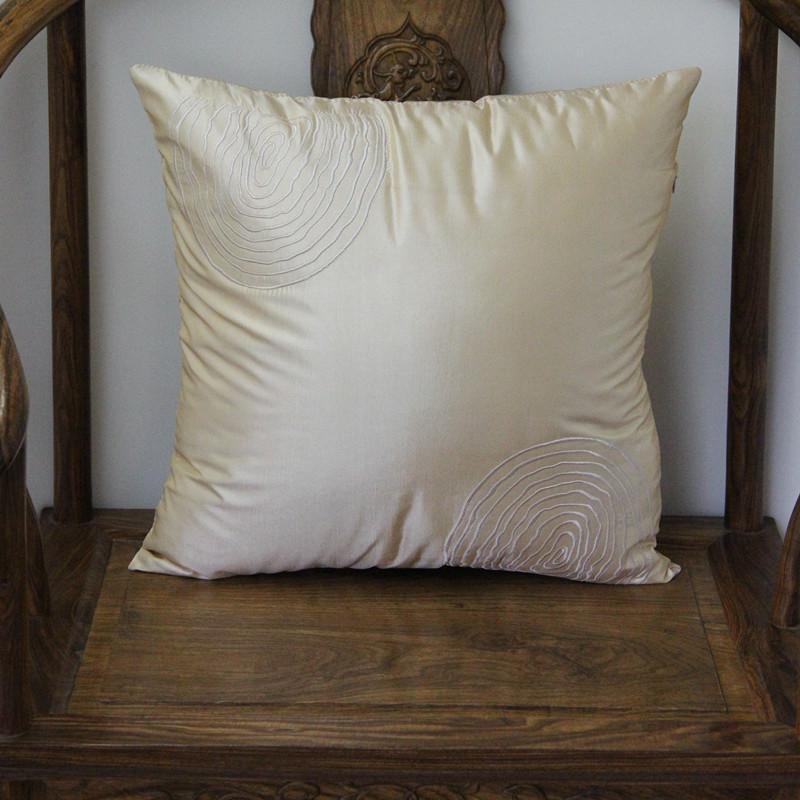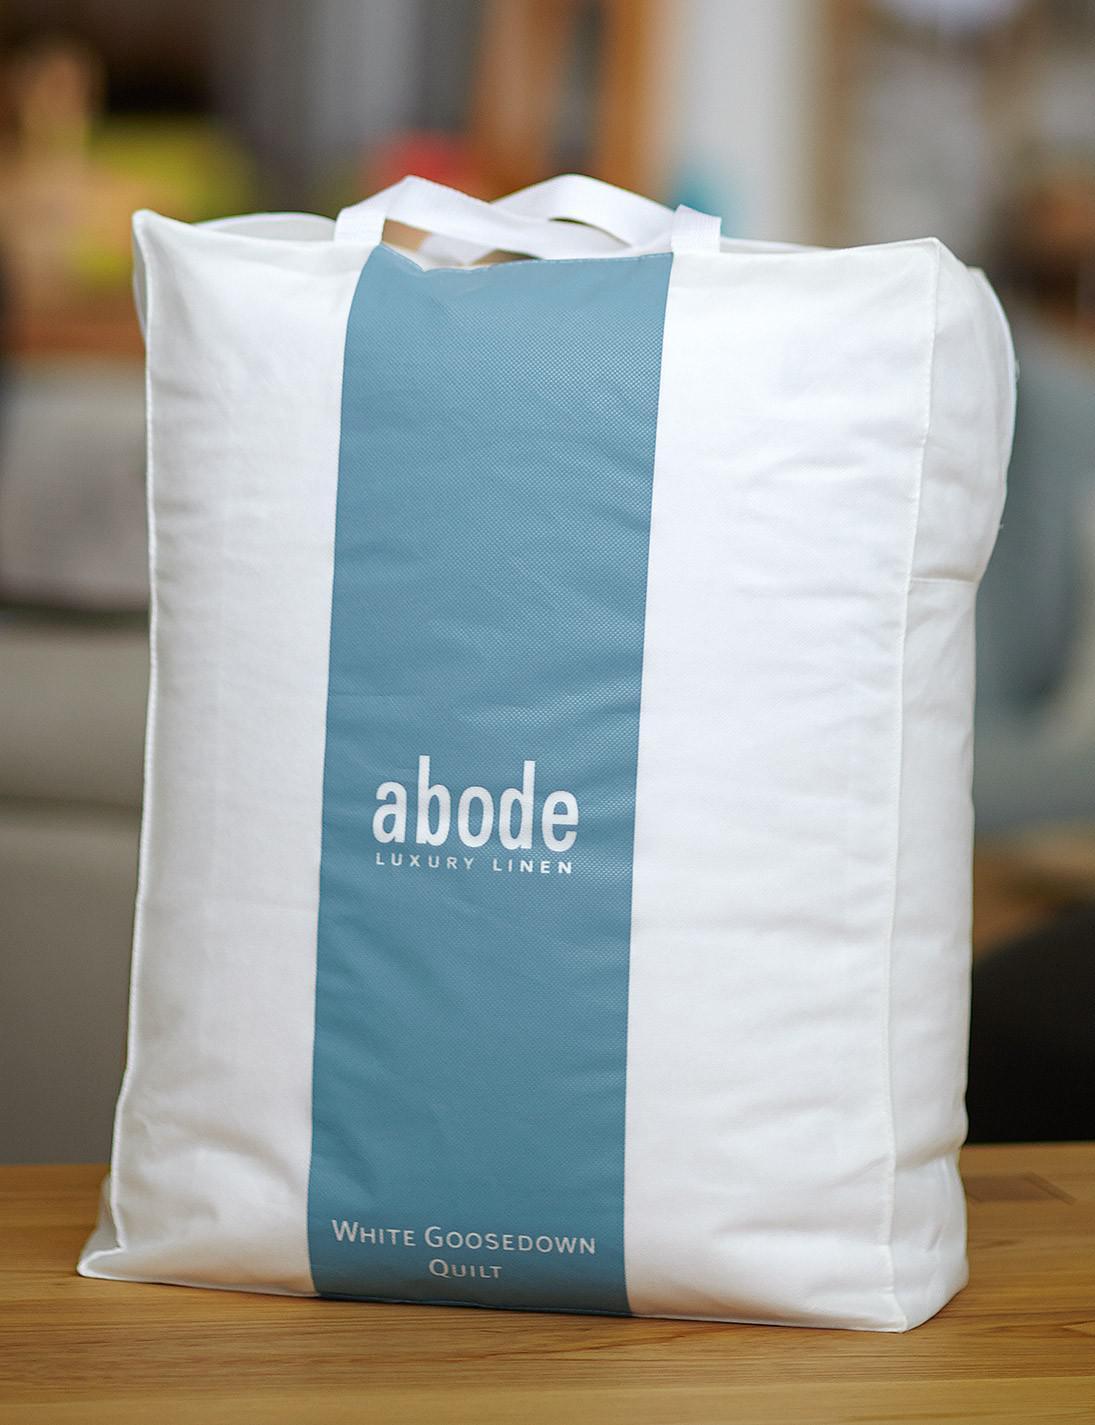The first image is the image on the left, the second image is the image on the right. Assess this claim about the two images: "The left and right image contains the same number of pillows in pillow bags.". Correct or not? Answer yes or no. No. The first image is the image on the left, the second image is the image on the right. Examine the images to the left and right. Is the description "One image shows an upright pillow shape with a wide blue stripe down the center, and the other image includes an off-white pillow shape with no stripe." accurate? Answer yes or no. Yes. 